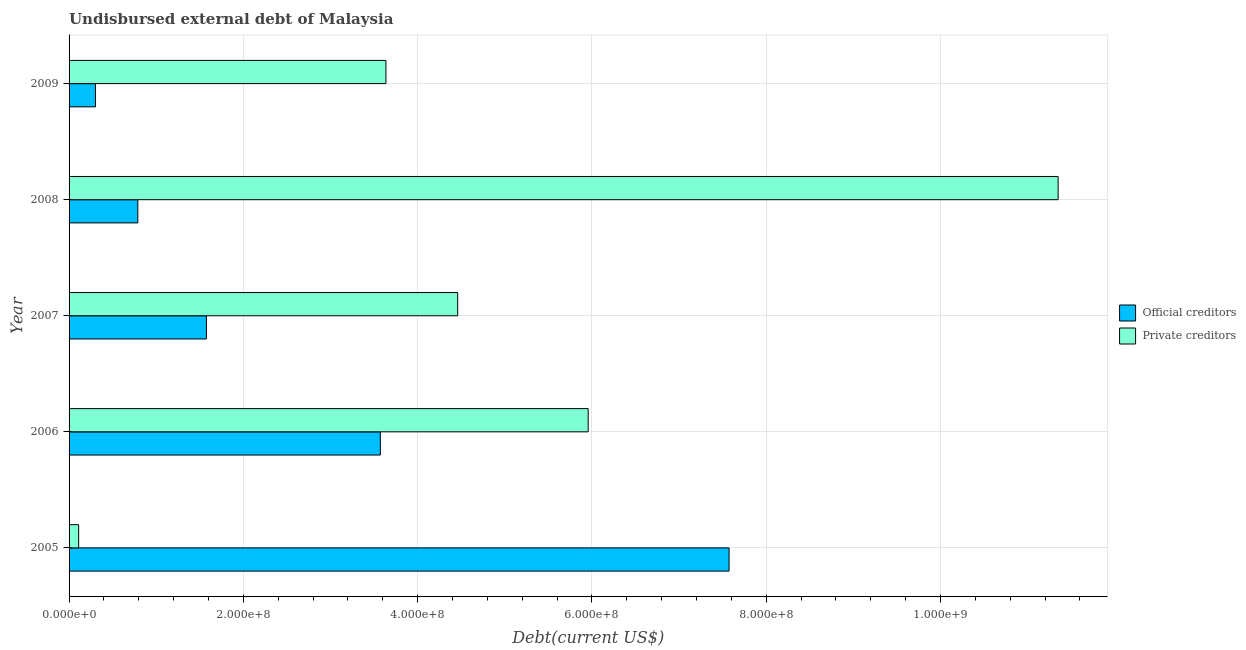How many groups of bars are there?
Ensure brevity in your answer.  5. Are the number of bars per tick equal to the number of legend labels?
Provide a short and direct response. Yes. Are the number of bars on each tick of the Y-axis equal?
Offer a terse response. Yes. How many bars are there on the 1st tick from the top?
Provide a short and direct response. 2. What is the label of the 5th group of bars from the top?
Your answer should be very brief. 2005. What is the undisbursed external debt of private creditors in 2005?
Your answer should be very brief. 1.10e+07. Across all years, what is the maximum undisbursed external debt of official creditors?
Ensure brevity in your answer.  7.57e+08. Across all years, what is the minimum undisbursed external debt of official creditors?
Offer a terse response. 3.03e+07. In which year was the undisbursed external debt of official creditors maximum?
Make the answer very short. 2005. What is the total undisbursed external debt of official creditors in the graph?
Provide a short and direct response. 1.38e+09. What is the difference between the undisbursed external debt of official creditors in 2005 and that in 2007?
Provide a short and direct response. 6.00e+08. What is the difference between the undisbursed external debt of private creditors in 2006 and the undisbursed external debt of official creditors in 2008?
Your response must be concise. 5.17e+08. What is the average undisbursed external debt of private creditors per year?
Make the answer very short. 5.10e+08. In the year 2007, what is the difference between the undisbursed external debt of official creditors and undisbursed external debt of private creditors?
Keep it short and to the point. -2.88e+08. In how many years, is the undisbursed external debt of official creditors greater than 160000000 US$?
Offer a very short reply. 2. What is the ratio of the undisbursed external debt of official creditors in 2005 to that in 2009?
Ensure brevity in your answer.  25.02. Is the difference between the undisbursed external debt of official creditors in 2005 and 2006 greater than the difference between the undisbursed external debt of private creditors in 2005 and 2006?
Your answer should be very brief. Yes. What is the difference between the highest and the second highest undisbursed external debt of private creditors?
Give a very brief answer. 5.39e+08. What is the difference between the highest and the lowest undisbursed external debt of official creditors?
Offer a terse response. 7.27e+08. In how many years, is the undisbursed external debt of private creditors greater than the average undisbursed external debt of private creditors taken over all years?
Make the answer very short. 2. What does the 1st bar from the top in 2007 represents?
Give a very brief answer. Private creditors. What does the 2nd bar from the bottom in 2008 represents?
Your answer should be very brief. Private creditors. How many bars are there?
Keep it short and to the point. 10. Are all the bars in the graph horizontal?
Provide a short and direct response. Yes. What is the difference between two consecutive major ticks on the X-axis?
Your answer should be very brief. 2.00e+08. How are the legend labels stacked?
Provide a short and direct response. Vertical. What is the title of the graph?
Give a very brief answer. Undisbursed external debt of Malaysia. What is the label or title of the X-axis?
Your answer should be very brief. Debt(current US$). What is the Debt(current US$) in Official creditors in 2005?
Your response must be concise. 7.57e+08. What is the Debt(current US$) in Private creditors in 2005?
Keep it short and to the point. 1.10e+07. What is the Debt(current US$) of Official creditors in 2006?
Your answer should be very brief. 3.57e+08. What is the Debt(current US$) in Private creditors in 2006?
Your answer should be compact. 5.96e+08. What is the Debt(current US$) in Official creditors in 2007?
Provide a short and direct response. 1.58e+08. What is the Debt(current US$) in Private creditors in 2007?
Make the answer very short. 4.46e+08. What is the Debt(current US$) of Official creditors in 2008?
Give a very brief answer. 7.89e+07. What is the Debt(current US$) of Private creditors in 2008?
Your response must be concise. 1.14e+09. What is the Debt(current US$) of Official creditors in 2009?
Your answer should be very brief. 3.03e+07. What is the Debt(current US$) of Private creditors in 2009?
Provide a short and direct response. 3.64e+08. Across all years, what is the maximum Debt(current US$) of Official creditors?
Give a very brief answer. 7.57e+08. Across all years, what is the maximum Debt(current US$) of Private creditors?
Your answer should be compact. 1.14e+09. Across all years, what is the minimum Debt(current US$) of Official creditors?
Provide a short and direct response. 3.03e+07. Across all years, what is the minimum Debt(current US$) of Private creditors?
Provide a short and direct response. 1.10e+07. What is the total Debt(current US$) in Official creditors in the graph?
Your response must be concise. 1.38e+09. What is the total Debt(current US$) in Private creditors in the graph?
Your answer should be very brief. 2.55e+09. What is the difference between the Debt(current US$) in Official creditors in 2005 and that in 2006?
Ensure brevity in your answer.  4.00e+08. What is the difference between the Debt(current US$) of Private creditors in 2005 and that in 2006?
Offer a terse response. -5.85e+08. What is the difference between the Debt(current US$) of Official creditors in 2005 and that in 2007?
Keep it short and to the point. 6.00e+08. What is the difference between the Debt(current US$) of Private creditors in 2005 and that in 2007?
Your answer should be compact. -4.35e+08. What is the difference between the Debt(current US$) of Official creditors in 2005 and that in 2008?
Provide a short and direct response. 6.79e+08. What is the difference between the Debt(current US$) of Private creditors in 2005 and that in 2008?
Provide a short and direct response. -1.12e+09. What is the difference between the Debt(current US$) in Official creditors in 2005 and that in 2009?
Your answer should be very brief. 7.27e+08. What is the difference between the Debt(current US$) of Private creditors in 2005 and that in 2009?
Your answer should be very brief. -3.53e+08. What is the difference between the Debt(current US$) of Official creditors in 2006 and that in 2007?
Offer a terse response. 2.00e+08. What is the difference between the Debt(current US$) of Private creditors in 2006 and that in 2007?
Your answer should be compact. 1.50e+08. What is the difference between the Debt(current US$) of Official creditors in 2006 and that in 2008?
Provide a short and direct response. 2.78e+08. What is the difference between the Debt(current US$) of Private creditors in 2006 and that in 2008?
Provide a short and direct response. -5.39e+08. What is the difference between the Debt(current US$) in Official creditors in 2006 and that in 2009?
Provide a short and direct response. 3.27e+08. What is the difference between the Debt(current US$) of Private creditors in 2006 and that in 2009?
Offer a very short reply. 2.32e+08. What is the difference between the Debt(current US$) of Official creditors in 2007 and that in 2008?
Your answer should be very brief. 7.87e+07. What is the difference between the Debt(current US$) of Private creditors in 2007 and that in 2008?
Give a very brief answer. -6.89e+08. What is the difference between the Debt(current US$) of Official creditors in 2007 and that in 2009?
Give a very brief answer. 1.27e+08. What is the difference between the Debt(current US$) of Private creditors in 2007 and that in 2009?
Ensure brevity in your answer.  8.24e+07. What is the difference between the Debt(current US$) in Official creditors in 2008 and that in 2009?
Make the answer very short. 4.86e+07. What is the difference between the Debt(current US$) of Private creditors in 2008 and that in 2009?
Keep it short and to the point. 7.71e+08. What is the difference between the Debt(current US$) in Official creditors in 2005 and the Debt(current US$) in Private creditors in 2006?
Offer a very short reply. 1.62e+08. What is the difference between the Debt(current US$) in Official creditors in 2005 and the Debt(current US$) in Private creditors in 2007?
Give a very brief answer. 3.11e+08. What is the difference between the Debt(current US$) of Official creditors in 2005 and the Debt(current US$) of Private creditors in 2008?
Offer a terse response. -3.78e+08. What is the difference between the Debt(current US$) of Official creditors in 2005 and the Debt(current US$) of Private creditors in 2009?
Offer a very short reply. 3.94e+08. What is the difference between the Debt(current US$) of Official creditors in 2006 and the Debt(current US$) of Private creditors in 2007?
Ensure brevity in your answer.  -8.88e+07. What is the difference between the Debt(current US$) in Official creditors in 2006 and the Debt(current US$) in Private creditors in 2008?
Ensure brevity in your answer.  -7.78e+08. What is the difference between the Debt(current US$) of Official creditors in 2006 and the Debt(current US$) of Private creditors in 2009?
Make the answer very short. -6.41e+06. What is the difference between the Debt(current US$) in Official creditors in 2007 and the Debt(current US$) in Private creditors in 2008?
Offer a terse response. -9.77e+08. What is the difference between the Debt(current US$) in Official creditors in 2007 and the Debt(current US$) in Private creditors in 2009?
Offer a terse response. -2.06e+08. What is the difference between the Debt(current US$) in Official creditors in 2008 and the Debt(current US$) in Private creditors in 2009?
Offer a terse response. -2.85e+08. What is the average Debt(current US$) of Official creditors per year?
Give a very brief answer. 2.76e+08. What is the average Debt(current US$) of Private creditors per year?
Offer a very short reply. 5.10e+08. In the year 2005, what is the difference between the Debt(current US$) of Official creditors and Debt(current US$) of Private creditors?
Your answer should be very brief. 7.46e+08. In the year 2006, what is the difference between the Debt(current US$) of Official creditors and Debt(current US$) of Private creditors?
Ensure brevity in your answer.  -2.38e+08. In the year 2007, what is the difference between the Debt(current US$) of Official creditors and Debt(current US$) of Private creditors?
Ensure brevity in your answer.  -2.88e+08. In the year 2008, what is the difference between the Debt(current US$) in Official creditors and Debt(current US$) in Private creditors?
Give a very brief answer. -1.06e+09. In the year 2009, what is the difference between the Debt(current US$) of Official creditors and Debt(current US$) of Private creditors?
Provide a succinct answer. -3.33e+08. What is the ratio of the Debt(current US$) in Official creditors in 2005 to that in 2006?
Offer a terse response. 2.12. What is the ratio of the Debt(current US$) of Private creditors in 2005 to that in 2006?
Make the answer very short. 0.02. What is the ratio of the Debt(current US$) in Official creditors in 2005 to that in 2007?
Your answer should be very brief. 4.81. What is the ratio of the Debt(current US$) in Private creditors in 2005 to that in 2007?
Offer a very short reply. 0.02. What is the ratio of the Debt(current US$) of Official creditors in 2005 to that in 2008?
Make the answer very short. 9.6. What is the ratio of the Debt(current US$) in Private creditors in 2005 to that in 2008?
Ensure brevity in your answer.  0.01. What is the ratio of the Debt(current US$) in Official creditors in 2005 to that in 2009?
Ensure brevity in your answer.  25.02. What is the ratio of the Debt(current US$) of Private creditors in 2005 to that in 2009?
Your response must be concise. 0.03. What is the ratio of the Debt(current US$) in Official creditors in 2006 to that in 2007?
Provide a short and direct response. 2.27. What is the ratio of the Debt(current US$) in Private creditors in 2006 to that in 2007?
Your answer should be compact. 1.34. What is the ratio of the Debt(current US$) of Official creditors in 2006 to that in 2008?
Your answer should be very brief. 4.53. What is the ratio of the Debt(current US$) in Private creditors in 2006 to that in 2008?
Keep it short and to the point. 0.52. What is the ratio of the Debt(current US$) in Official creditors in 2006 to that in 2009?
Your response must be concise. 11.8. What is the ratio of the Debt(current US$) in Private creditors in 2006 to that in 2009?
Your response must be concise. 1.64. What is the ratio of the Debt(current US$) in Official creditors in 2007 to that in 2008?
Keep it short and to the point. 2. What is the ratio of the Debt(current US$) of Private creditors in 2007 to that in 2008?
Offer a very short reply. 0.39. What is the ratio of the Debt(current US$) in Official creditors in 2007 to that in 2009?
Give a very brief answer. 5.21. What is the ratio of the Debt(current US$) of Private creditors in 2007 to that in 2009?
Keep it short and to the point. 1.23. What is the ratio of the Debt(current US$) in Official creditors in 2008 to that in 2009?
Provide a succinct answer. 2.61. What is the ratio of the Debt(current US$) of Private creditors in 2008 to that in 2009?
Your answer should be very brief. 3.12. What is the difference between the highest and the second highest Debt(current US$) of Official creditors?
Offer a terse response. 4.00e+08. What is the difference between the highest and the second highest Debt(current US$) of Private creditors?
Ensure brevity in your answer.  5.39e+08. What is the difference between the highest and the lowest Debt(current US$) in Official creditors?
Keep it short and to the point. 7.27e+08. What is the difference between the highest and the lowest Debt(current US$) of Private creditors?
Ensure brevity in your answer.  1.12e+09. 